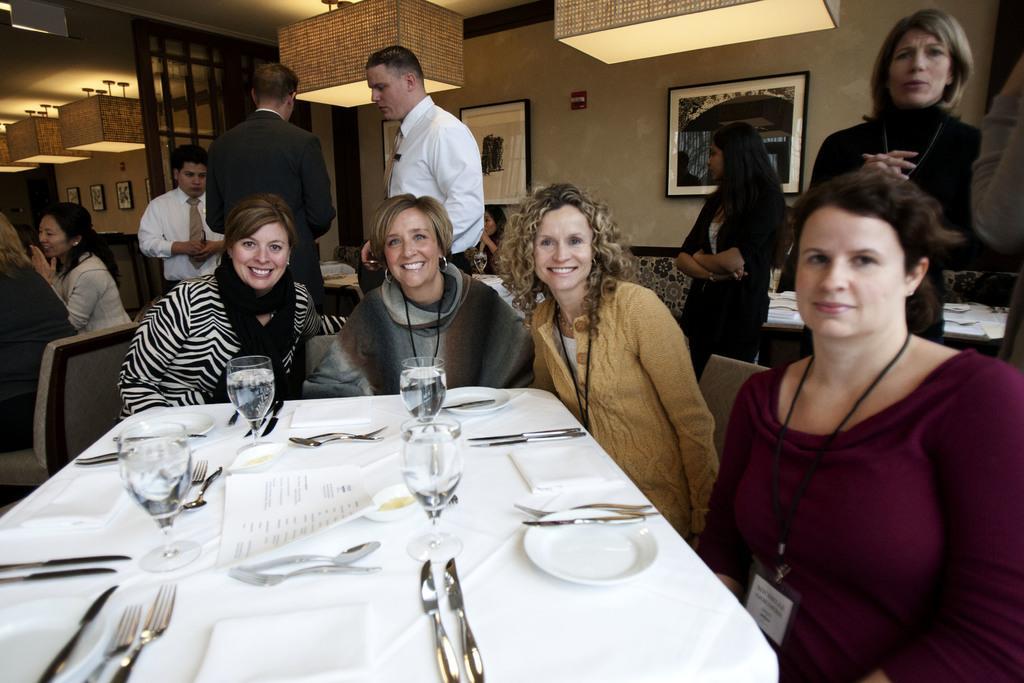Please provide a concise description of this image. In this picture there are few people sitting on the chair. There is a glass , knife and fork on the table. There is a frame on the wall. There is a light. 